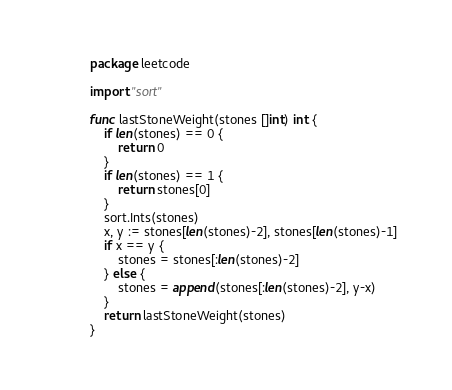Convert code to text. <code><loc_0><loc_0><loc_500><loc_500><_Go_>package leetcode

import "sort"

func lastStoneWeight(stones []int) int {
	if len(stones) == 0 {
		return 0
	}
	if len(stones) == 1 {
		return stones[0]
	}
	sort.Ints(stones)
	x, y := stones[len(stones)-2], stones[len(stones)-1]
	if x == y {
		stones = stones[:len(stones)-2]
	} else {
		stones = append(stones[:len(stones)-2], y-x)
	}
	return lastStoneWeight(stones)
}
</code> 